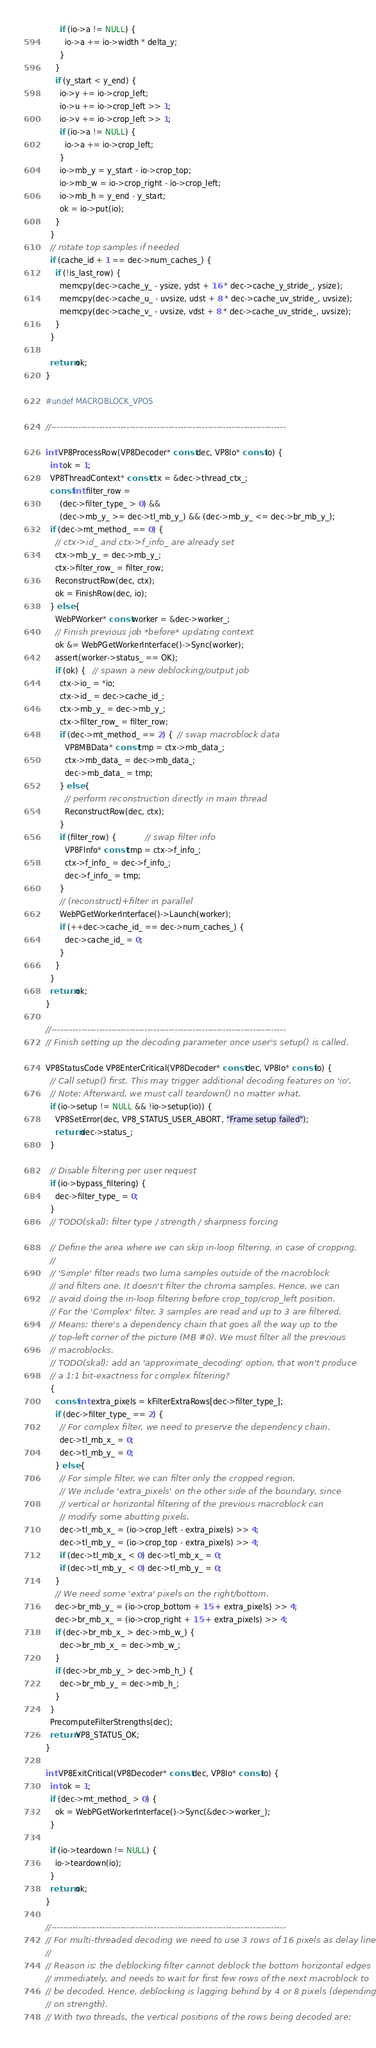Convert code to text. <code><loc_0><loc_0><loc_500><loc_500><_C_>      if (io->a != NULL) {
        io->a += io->width * delta_y;
      }
    }
    if (y_start < y_end) {
      io->y += io->crop_left;
      io->u += io->crop_left >> 1;
      io->v += io->crop_left >> 1;
      if (io->a != NULL) {
        io->a += io->crop_left;
      }
      io->mb_y = y_start - io->crop_top;
      io->mb_w = io->crop_right - io->crop_left;
      io->mb_h = y_end - y_start;
      ok = io->put(io);
    }
  }
  // rotate top samples if needed
  if (cache_id + 1 == dec->num_caches_) {
    if (!is_last_row) {
      memcpy(dec->cache_y_ - ysize, ydst + 16 * dec->cache_y_stride_, ysize);
      memcpy(dec->cache_u_ - uvsize, udst + 8 * dec->cache_uv_stride_, uvsize);
      memcpy(dec->cache_v_ - uvsize, vdst + 8 * dec->cache_uv_stride_, uvsize);
    }
  }

  return ok;
}

#undef MACROBLOCK_VPOS

//------------------------------------------------------------------------------

int VP8ProcessRow(VP8Decoder* const dec, VP8Io* const io) {
  int ok = 1;
  VP8ThreadContext* const ctx = &dec->thread_ctx_;
  const int filter_row =
      (dec->filter_type_ > 0) &&
      (dec->mb_y_ >= dec->tl_mb_y_) && (dec->mb_y_ <= dec->br_mb_y_);
  if (dec->mt_method_ == 0) {
    // ctx->id_ and ctx->f_info_ are already set
    ctx->mb_y_ = dec->mb_y_;
    ctx->filter_row_ = filter_row;
    ReconstructRow(dec, ctx);
    ok = FinishRow(dec, io);
  } else {
    WebPWorker* const worker = &dec->worker_;
    // Finish previous job *before* updating context
    ok &= WebPGetWorkerInterface()->Sync(worker);
    assert(worker->status_ == OK);
    if (ok) {   // spawn a new deblocking/output job
      ctx->io_ = *io;
      ctx->id_ = dec->cache_id_;
      ctx->mb_y_ = dec->mb_y_;
      ctx->filter_row_ = filter_row;
      if (dec->mt_method_ == 2) {  // swap macroblock data
        VP8MBData* const tmp = ctx->mb_data_;
        ctx->mb_data_ = dec->mb_data_;
        dec->mb_data_ = tmp;
      } else {
        // perform reconstruction directly in main thread
        ReconstructRow(dec, ctx);
      }
      if (filter_row) {            // swap filter info
        VP8FInfo* const tmp = ctx->f_info_;
        ctx->f_info_ = dec->f_info_;
        dec->f_info_ = tmp;
      }
      // (reconstruct)+filter in parallel
      WebPGetWorkerInterface()->Launch(worker);
      if (++dec->cache_id_ == dec->num_caches_) {
        dec->cache_id_ = 0;
      }
    }
  }
  return ok;
}

//------------------------------------------------------------------------------
// Finish setting up the decoding parameter once user's setup() is called.

VP8StatusCode VP8EnterCritical(VP8Decoder* const dec, VP8Io* const io) {
  // Call setup() first. This may trigger additional decoding features on 'io'.
  // Note: Afterward, we must call teardown() no matter what.
  if (io->setup != NULL && !io->setup(io)) {
    VP8SetError(dec, VP8_STATUS_USER_ABORT, "Frame setup failed");
    return dec->status_;
  }

  // Disable filtering per user request
  if (io->bypass_filtering) {
    dec->filter_type_ = 0;
  }
  // TODO(skal): filter type / strength / sharpness forcing

  // Define the area where we can skip in-loop filtering, in case of cropping.
  //
  // 'Simple' filter reads two luma samples outside of the macroblock
  // and filters one. It doesn't filter the chroma samples. Hence, we can
  // avoid doing the in-loop filtering before crop_top/crop_left position.
  // For the 'Complex' filter, 3 samples are read and up to 3 are filtered.
  // Means: there's a dependency chain that goes all the way up to the
  // top-left corner of the picture (MB #0). We must filter all the previous
  // macroblocks.
  // TODO(skal): add an 'approximate_decoding' option, that won't produce
  // a 1:1 bit-exactness for complex filtering?
  {
    const int extra_pixels = kFilterExtraRows[dec->filter_type_];
    if (dec->filter_type_ == 2) {
      // For complex filter, we need to preserve the dependency chain.
      dec->tl_mb_x_ = 0;
      dec->tl_mb_y_ = 0;
    } else {
      // For simple filter, we can filter only the cropped region.
      // We include 'extra_pixels' on the other side of the boundary, since
      // vertical or horizontal filtering of the previous macroblock can
      // modify some abutting pixels.
      dec->tl_mb_x_ = (io->crop_left - extra_pixels) >> 4;
      dec->tl_mb_y_ = (io->crop_top - extra_pixels) >> 4;
      if (dec->tl_mb_x_ < 0) dec->tl_mb_x_ = 0;
      if (dec->tl_mb_y_ < 0) dec->tl_mb_y_ = 0;
    }
    // We need some 'extra' pixels on the right/bottom.
    dec->br_mb_y_ = (io->crop_bottom + 15 + extra_pixels) >> 4;
    dec->br_mb_x_ = (io->crop_right + 15 + extra_pixels) >> 4;
    if (dec->br_mb_x_ > dec->mb_w_) {
      dec->br_mb_x_ = dec->mb_w_;
    }
    if (dec->br_mb_y_ > dec->mb_h_) {
      dec->br_mb_y_ = dec->mb_h_;
    }
  }
  PrecomputeFilterStrengths(dec);
  return VP8_STATUS_OK;
}

int VP8ExitCritical(VP8Decoder* const dec, VP8Io* const io) {
  int ok = 1;
  if (dec->mt_method_ > 0) {
    ok = WebPGetWorkerInterface()->Sync(&dec->worker_);
  }

  if (io->teardown != NULL) {
    io->teardown(io);
  }
  return ok;
}

//------------------------------------------------------------------------------
// For multi-threaded decoding we need to use 3 rows of 16 pixels as delay line.
//
// Reason is: the deblocking filter cannot deblock the bottom horizontal edges
// immediately, and needs to wait for first few rows of the next macroblock to
// be decoded. Hence, deblocking is lagging behind by 4 or 8 pixels (depending
// on strength).
// With two threads, the vertical positions of the rows being decoded are:</code> 